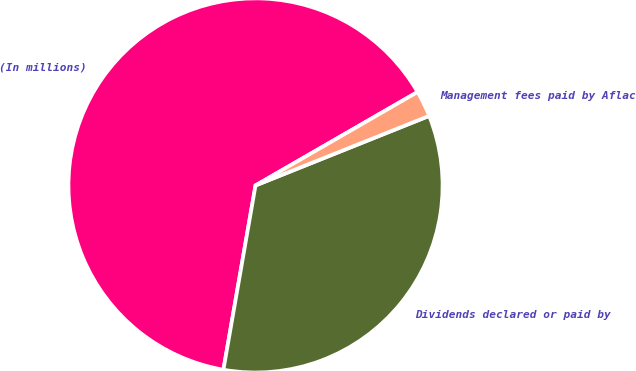Convert chart. <chart><loc_0><loc_0><loc_500><loc_500><pie_chart><fcel>(In millions)<fcel>Dividends declared or paid by<fcel>Management fees paid by Aflac<nl><fcel>63.93%<fcel>33.81%<fcel>2.26%<nl></chart> 